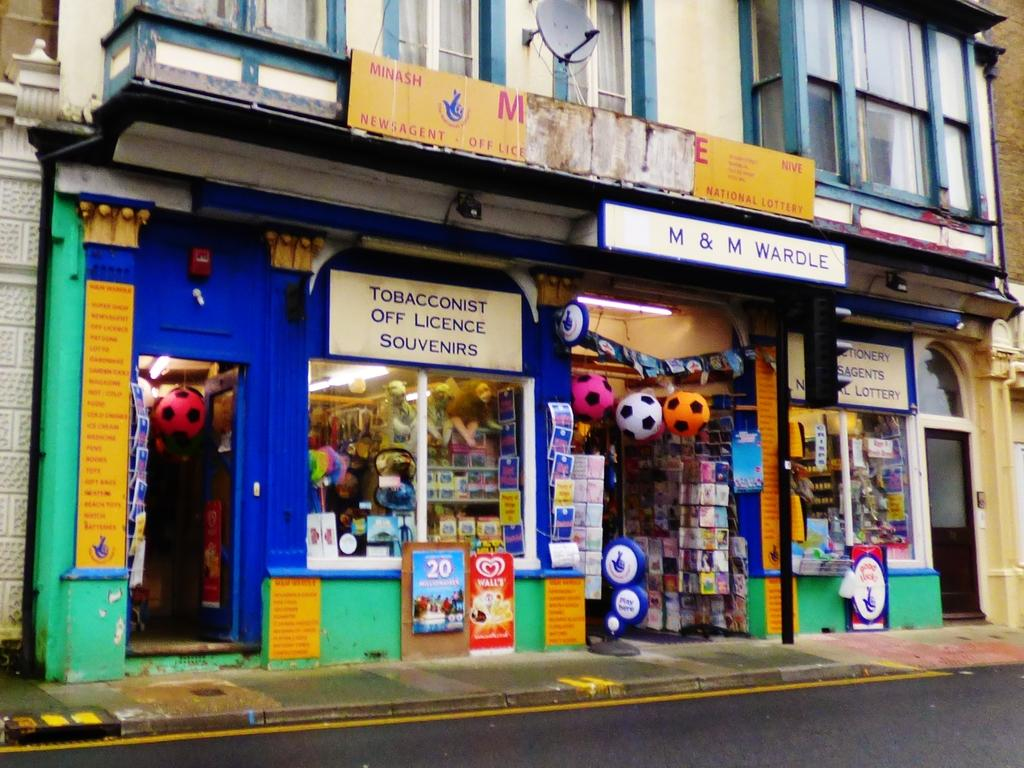Provide a one-sentence caption for the provided image. Several advertisements and signs adorn the M&M Wardle store. 